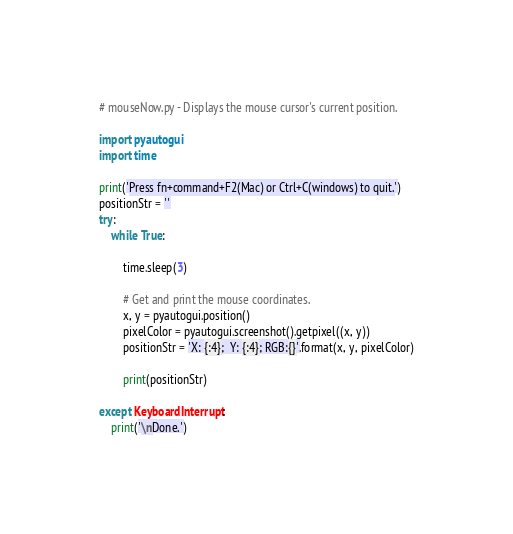<code> <loc_0><loc_0><loc_500><loc_500><_Python_># mouseNow.py - Displays the mouse cursor's current position.

import pyautogui
import time

print('Press fn+command+F2(Mac) or Ctrl+C(windows) to quit.')
positionStr = ''
try:
    while True:

        time.sleep(3)

        # Get and print the mouse coordinates.
        x, y = pyautogui.position()
        pixelColor = pyautogui.screenshot().getpixel((x, y))
        positionStr = 'X: {:4};  Y: {:4}; RGB:{}'.format(x, y, pixelColor)

        print(positionStr)

except KeyboardInterrupt:
    print('\nDone.')


</code> 